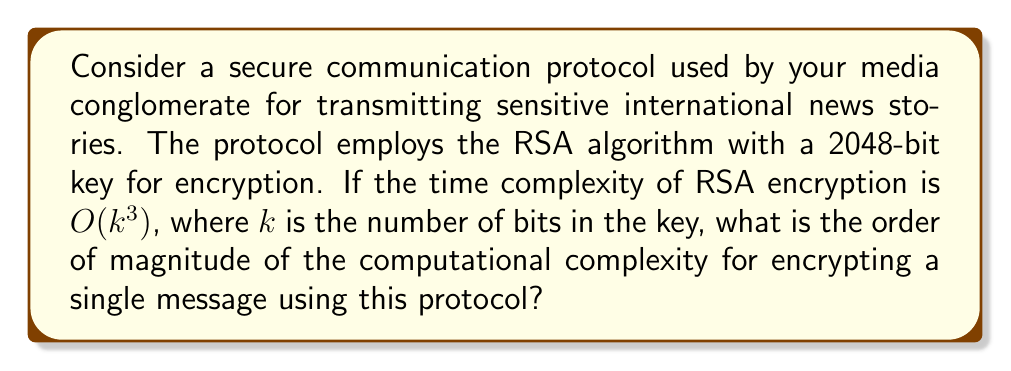Solve this math problem. To evaluate the computational complexity of this cryptographic protocol, we need to follow these steps:

1. Identify the key size:
   The protocol uses a 2048-bit RSA key, so $k = 2048$.

2. Recall the time complexity of RSA encryption:
   The question states that the time complexity is $O(k^3)$.

3. Substitute the key size into the complexity function:
   $$O((2048)^3)$$

4. Evaluate the exponent:
   $$O(2048^3) = O(8,589,934,592)$$

5. Express the result in scientific notation:
   $$O(8.59 \times 10^9)$$

6. Determine the order of magnitude:
   The order of magnitude is $10^9$ or billion.

Therefore, the computational complexity for encrypting a single message using this protocol is on the order of billions of operations.
Answer: $O(10^9)$ 